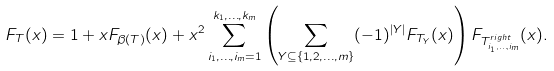<formula> <loc_0><loc_0><loc_500><loc_500>F _ { T } ( x ) = 1 + x F _ { \beta ( T ) } ( x ) + x ^ { 2 } \sum _ { i _ { 1 } , \dots , i _ { m } = 1 } ^ { k _ { 1 } , \dots , k _ { m } } \left ( \sum _ { Y \subseteq \{ 1 , 2 , \dots , m \} } ( - 1 ) ^ { | Y | } F _ { T _ { Y } } ( x ) \right ) F _ { T ^ { r i g h t } _ { i _ { 1 } , \dots , i _ { m } } } ( x ) .</formula> 